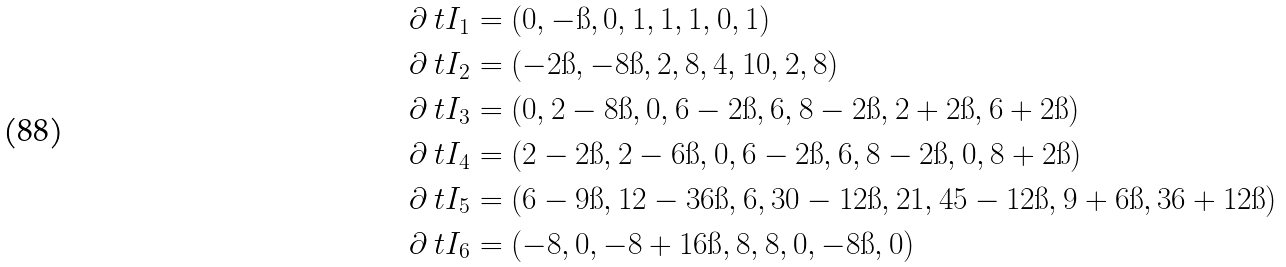Convert formula to latex. <formula><loc_0><loc_0><loc_500><loc_500>\partial _ { \ } t I _ { 1 } & = ( 0 , - \i , 0 , 1 , 1 , 1 , 0 , 1 ) \\ \partial _ { \ } t I _ { 2 } & = ( - 2 \i , - 8 \i , 2 , 8 , 4 , 1 0 , 2 , 8 ) \\ \partial _ { \ } t I _ { 3 } & = ( 0 , 2 - 8 \i , 0 , 6 - 2 \i , 6 , 8 - 2 \i , 2 + 2 \i , 6 + 2 \i ) \\ \partial _ { \ } t I _ { 4 } & = ( 2 - 2 \i , 2 - 6 \i , 0 , 6 - 2 \i , 6 , 8 - 2 \i , 0 , 8 + 2 \i ) \\ \partial _ { \ } t I _ { 5 } & = ( 6 - 9 \i , 1 2 - 3 6 \i , 6 , 3 0 - 1 2 \i , 2 1 , 4 5 - 1 2 \i , 9 + 6 \i , 3 6 + 1 2 \i ) \\ \partial _ { \ } t I _ { 6 } & = ( - 8 , 0 , - 8 + 1 6 \i , 8 , 8 , 0 , - 8 \i , 0 )</formula> 